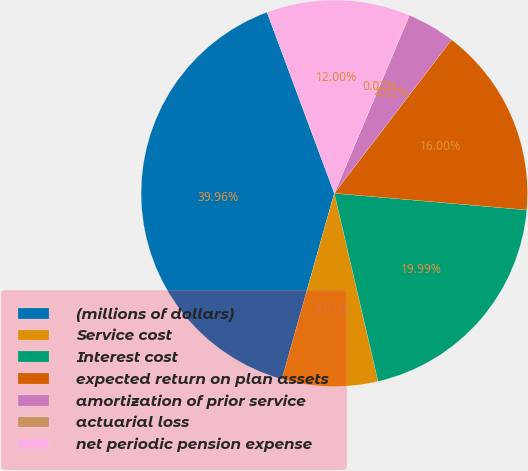<chart> <loc_0><loc_0><loc_500><loc_500><pie_chart><fcel>(millions of dollars)<fcel>Service cost<fcel>Interest cost<fcel>expected return on plan assets<fcel>amortization of prior service<fcel>actuarial loss<fcel>net periodic pension expense<nl><fcel>39.96%<fcel>8.01%<fcel>19.99%<fcel>16.0%<fcel>4.02%<fcel>0.02%<fcel>12.0%<nl></chart> 